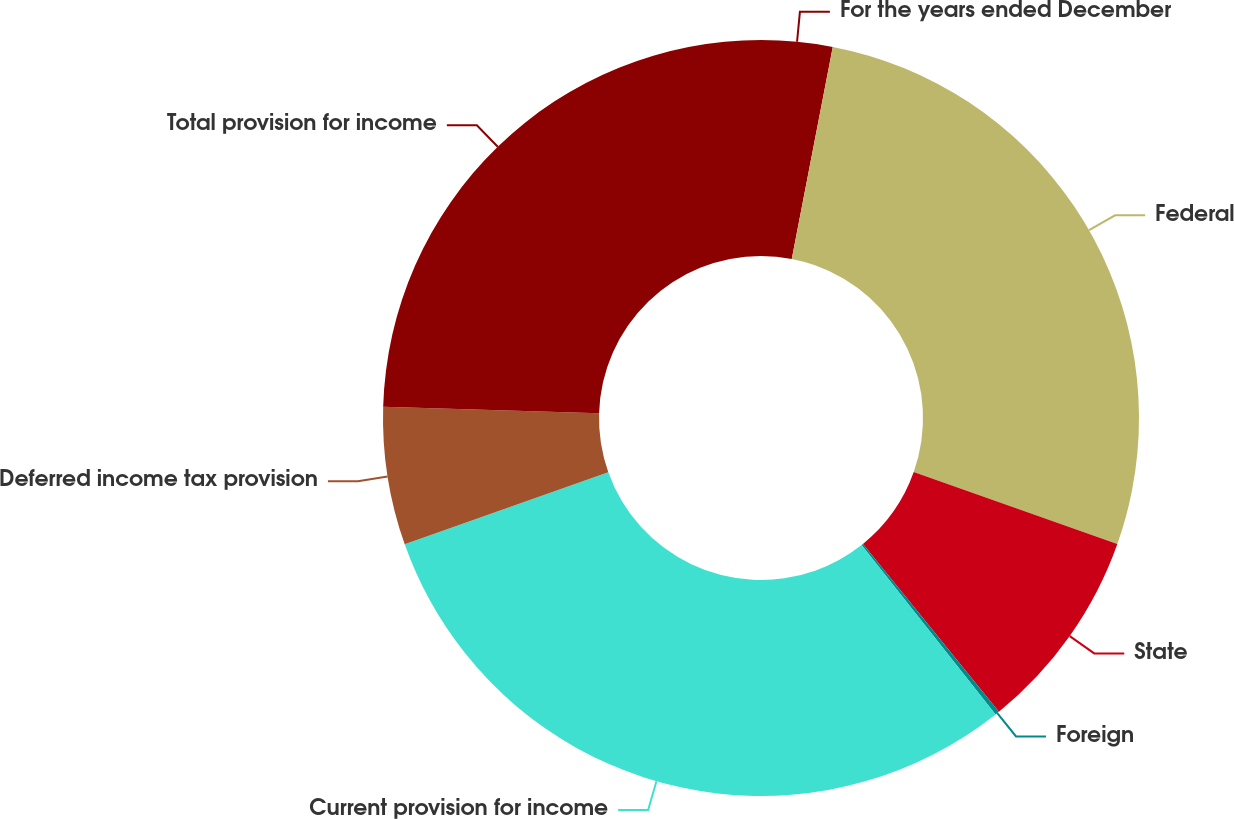<chart> <loc_0><loc_0><loc_500><loc_500><pie_chart><fcel>For the years ended December<fcel>Federal<fcel>State<fcel>Foreign<fcel>Current provision for income<fcel>Deferred income tax provision<fcel>Total provision for income<nl><fcel>3.04%<fcel>27.37%<fcel>8.75%<fcel>0.18%<fcel>30.23%<fcel>5.9%<fcel>24.52%<nl></chart> 